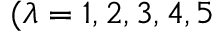Convert formula to latex. <formula><loc_0><loc_0><loc_500><loc_500>( \lambda = 1 , 2 , 3 , 4 , 5</formula> 